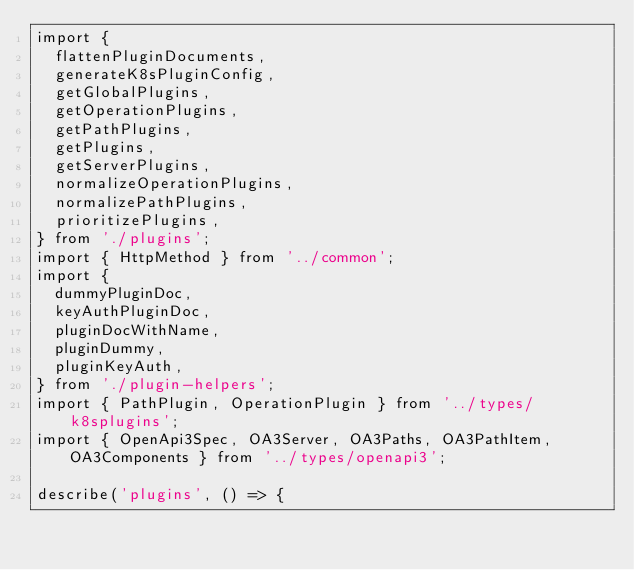Convert code to text. <code><loc_0><loc_0><loc_500><loc_500><_TypeScript_>import {
  flattenPluginDocuments,
  generateK8sPluginConfig,
  getGlobalPlugins,
  getOperationPlugins,
  getPathPlugins,
  getPlugins,
  getServerPlugins,
  normalizeOperationPlugins,
  normalizePathPlugins,
  prioritizePlugins,
} from './plugins';
import { HttpMethod } from '../common';
import {
  dummyPluginDoc,
  keyAuthPluginDoc,
  pluginDocWithName,
  pluginDummy,
  pluginKeyAuth,
} from './plugin-helpers';
import { PathPlugin, OperationPlugin } from '../types/k8splugins';
import { OpenApi3Spec, OA3Server, OA3Paths, OA3PathItem, OA3Components } from '../types/openapi3';

describe('plugins', () => {</code> 